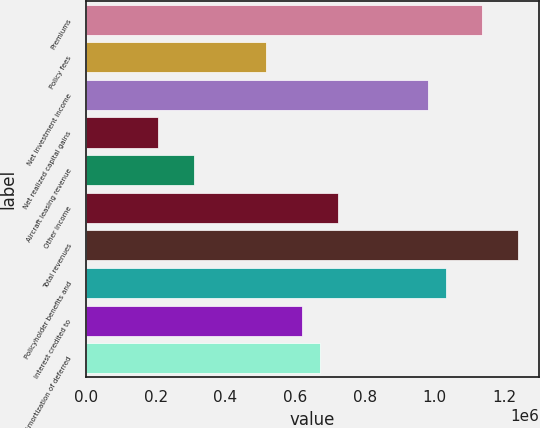Convert chart. <chart><loc_0><loc_0><loc_500><loc_500><bar_chart><fcel>Premiums<fcel>Policy fees<fcel>Net investment income<fcel>Net realized capital gains<fcel>Aircraft leasing revenue<fcel>Other income<fcel>Total revenues<fcel>Policyholder benefits and<fcel>Interest credited to<fcel>Amortization of deferred<nl><fcel>1.13427e+06<fcel>515581<fcel>979599<fcel>206236<fcel>309351<fcel>721811<fcel>1.23739e+06<fcel>1.03116e+06<fcel>618696<fcel>670254<nl></chart> 